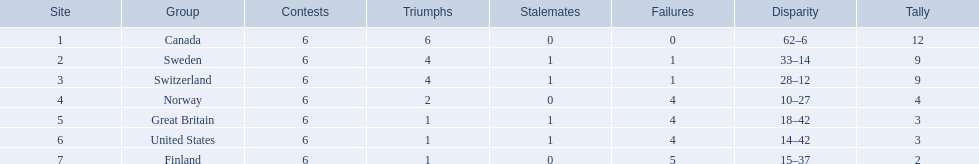What are all the teams? Canada, Sweden, Switzerland, Norway, Great Britain, United States, Finland. What were their points? 12, 9, 9, 4, 3, 3, 2. What about just switzerland and great britain? 9, 3. Now, which of those teams scored higher? Switzerland. 